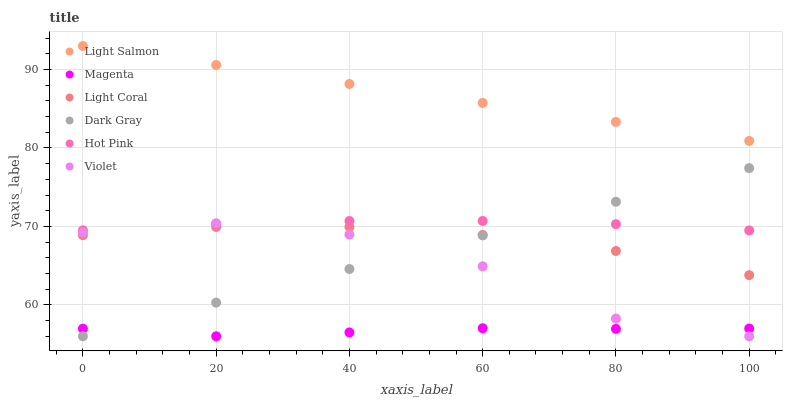Does Magenta have the minimum area under the curve?
Answer yes or no. Yes. Does Light Salmon have the maximum area under the curve?
Answer yes or no. Yes. Does Hot Pink have the minimum area under the curve?
Answer yes or no. No. Does Hot Pink have the maximum area under the curve?
Answer yes or no. No. Is Dark Gray the smoothest?
Answer yes or no. Yes. Is Violet the roughest?
Answer yes or no. Yes. Is Light Salmon the smoothest?
Answer yes or no. No. Is Light Salmon the roughest?
Answer yes or no. No. Does Dark Gray have the lowest value?
Answer yes or no. Yes. Does Hot Pink have the lowest value?
Answer yes or no. No. Does Light Salmon have the highest value?
Answer yes or no. Yes. Does Hot Pink have the highest value?
Answer yes or no. No. Is Violet less than Light Salmon?
Answer yes or no. Yes. Is Light Salmon greater than Violet?
Answer yes or no. Yes. Does Magenta intersect Violet?
Answer yes or no. Yes. Is Magenta less than Violet?
Answer yes or no. No. Is Magenta greater than Violet?
Answer yes or no. No. Does Violet intersect Light Salmon?
Answer yes or no. No. 